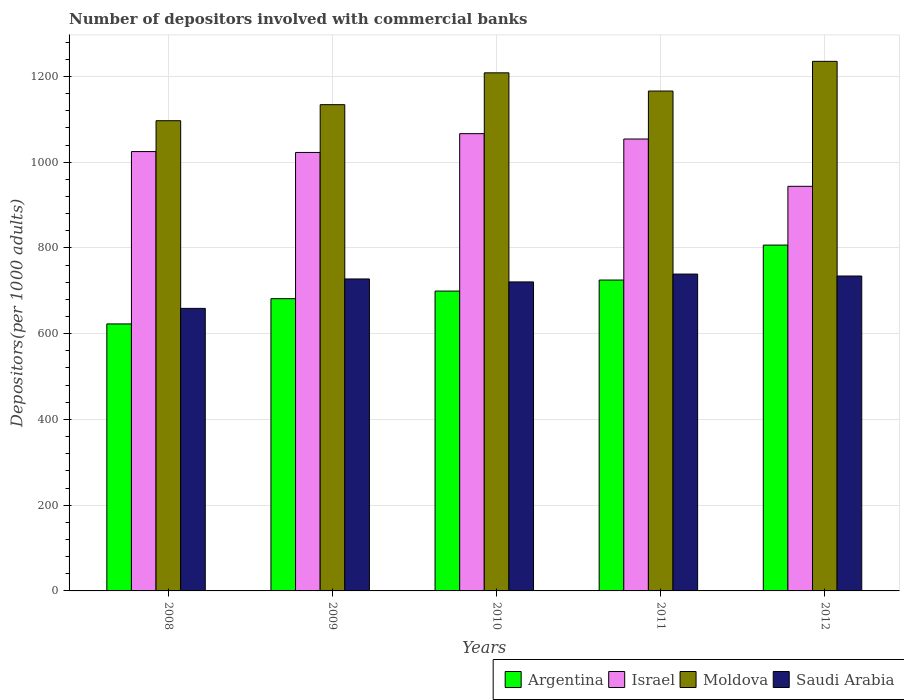How many groups of bars are there?
Give a very brief answer. 5. Are the number of bars per tick equal to the number of legend labels?
Provide a short and direct response. Yes. What is the number of depositors involved with commercial banks in Saudi Arabia in 2011?
Your answer should be very brief. 739.05. Across all years, what is the maximum number of depositors involved with commercial banks in Argentina?
Give a very brief answer. 806.63. Across all years, what is the minimum number of depositors involved with commercial banks in Argentina?
Your answer should be very brief. 622.73. In which year was the number of depositors involved with commercial banks in Israel minimum?
Your response must be concise. 2012. What is the total number of depositors involved with commercial banks in Israel in the graph?
Your answer should be very brief. 5111.81. What is the difference between the number of depositors involved with commercial banks in Argentina in 2011 and that in 2012?
Your answer should be very brief. -81.53. What is the difference between the number of depositors involved with commercial banks in Argentina in 2011 and the number of depositors involved with commercial banks in Moldova in 2009?
Offer a terse response. -409.07. What is the average number of depositors involved with commercial banks in Moldova per year?
Provide a succinct answer. 1168.08. In the year 2009, what is the difference between the number of depositors involved with commercial banks in Israel and number of depositors involved with commercial banks in Argentina?
Make the answer very short. 341.08. In how many years, is the number of depositors involved with commercial banks in Argentina greater than 880?
Your response must be concise. 0. What is the ratio of the number of depositors involved with commercial banks in Israel in 2008 to that in 2012?
Offer a very short reply. 1.09. Is the difference between the number of depositors involved with commercial banks in Israel in 2009 and 2010 greater than the difference between the number of depositors involved with commercial banks in Argentina in 2009 and 2010?
Your answer should be compact. No. What is the difference between the highest and the second highest number of depositors involved with commercial banks in Argentina?
Provide a short and direct response. 81.53. What is the difference between the highest and the lowest number of depositors involved with commercial banks in Argentina?
Ensure brevity in your answer.  183.9. Is the sum of the number of depositors involved with commercial banks in Israel in 2008 and 2011 greater than the maximum number of depositors involved with commercial banks in Moldova across all years?
Provide a short and direct response. Yes. Is it the case that in every year, the sum of the number of depositors involved with commercial banks in Israel and number of depositors involved with commercial banks in Argentina is greater than the sum of number of depositors involved with commercial banks in Moldova and number of depositors involved with commercial banks in Saudi Arabia?
Provide a succinct answer. Yes. What does the 4th bar from the right in 2012 represents?
Offer a very short reply. Argentina. How many bars are there?
Offer a terse response. 20. Does the graph contain any zero values?
Your response must be concise. No. How many legend labels are there?
Your response must be concise. 4. What is the title of the graph?
Your answer should be very brief. Number of depositors involved with commercial banks. What is the label or title of the Y-axis?
Keep it short and to the point. Depositors(per 1000 adults). What is the Depositors(per 1000 adults) of Argentina in 2008?
Your answer should be compact. 622.73. What is the Depositors(per 1000 adults) of Israel in 2008?
Give a very brief answer. 1024.76. What is the Depositors(per 1000 adults) of Moldova in 2008?
Provide a short and direct response. 1096.73. What is the Depositors(per 1000 adults) of Saudi Arabia in 2008?
Your answer should be very brief. 659. What is the Depositors(per 1000 adults) of Argentina in 2009?
Provide a short and direct response. 681.62. What is the Depositors(per 1000 adults) of Israel in 2009?
Give a very brief answer. 1022.7. What is the Depositors(per 1000 adults) of Moldova in 2009?
Keep it short and to the point. 1134.17. What is the Depositors(per 1000 adults) in Saudi Arabia in 2009?
Give a very brief answer. 727.65. What is the Depositors(per 1000 adults) of Argentina in 2010?
Give a very brief answer. 699.37. What is the Depositors(per 1000 adults) of Israel in 2010?
Your answer should be very brief. 1066.56. What is the Depositors(per 1000 adults) of Moldova in 2010?
Your answer should be compact. 1208.39. What is the Depositors(per 1000 adults) in Saudi Arabia in 2010?
Your answer should be very brief. 720.71. What is the Depositors(per 1000 adults) of Argentina in 2011?
Keep it short and to the point. 725.1. What is the Depositors(per 1000 adults) of Israel in 2011?
Give a very brief answer. 1054.06. What is the Depositors(per 1000 adults) in Moldova in 2011?
Offer a terse response. 1165.93. What is the Depositors(per 1000 adults) of Saudi Arabia in 2011?
Offer a very short reply. 739.05. What is the Depositors(per 1000 adults) in Argentina in 2012?
Ensure brevity in your answer.  806.63. What is the Depositors(per 1000 adults) in Israel in 2012?
Your response must be concise. 943.72. What is the Depositors(per 1000 adults) of Moldova in 2012?
Keep it short and to the point. 1235.18. What is the Depositors(per 1000 adults) in Saudi Arabia in 2012?
Provide a succinct answer. 734.51. Across all years, what is the maximum Depositors(per 1000 adults) in Argentina?
Give a very brief answer. 806.63. Across all years, what is the maximum Depositors(per 1000 adults) of Israel?
Ensure brevity in your answer.  1066.56. Across all years, what is the maximum Depositors(per 1000 adults) of Moldova?
Ensure brevity in your answer.  1235.18. Across all years, what is the maximum Depositors(per 1000 adults) in Saudi Arabia?
Offer a very short reply. 739.05. Across all years, what is the minimum Depositors(per 1000 adults) of Argentina?
Offer a terse response. 622.73. Across all years, what is the minimum Depositors(per 1000 adults) in Israel?
Your response must be concise. 943.72. Across all years, what is the minimum Depositors(per 1000 adults) of Moldova?
Keep it short and to the point. 1096.73. Across all years, what is the minimum Depositors(per 1000 adults) in Saudi Arabia?
Offer a terse response. 659. What is the total Depositors(per 1000 adults) of Argentina in the graph?
Keep it short and to the point. 3535.46. What is the total Depositors(per 1000 adults) of Israel in the graph?
Make the answer very short. 5111.81. What is the total Depositors(per 1000 adults) in Moldova in the graph?
Provide a succinct answer. 5840.41. What is the total Depositors(per 1000 adults) in Saudi Arabia in the graph?
Give a very brief answer. 3580.92. What is the difference between the Depositors(per 1000 adults) in Argentina in 2008 and that in 2009?
Offer a terse response. -58.89. What is the difference between the Depositors(per 1000 adults) of Israel in 2008 and that in 2009?
Provide a succinct answer. 2.06. What is the difference between the Depositors(per 1000 adults) of Moldova in 2008 and that in 2009?
Your answer should be very brief. -37.44. What is the difference between the Depositors(per 1000 adults) of Saudi Arabia in 2008 and that in 2009?
Provide a succinct answer. -68.64. What is the difference between the Depositors(per 1000 adults) of Argentina in 2008 and that in 2010?
Your answer should be compact. -76.64. What is the difference between the Depositors(per 1000 adults) of Israel in 2008 and that in 2010?
Provide a short and direct response. -41.8. What is the difference between the Depositors(per 1000 adults) in Moldova in 2008 and that in 2010?
Your response must be concise. -111.66. What is the difference between the Depositors(per 1000 adults) in Saudi Arabia in 2008 and that in 2010?
Offer a very short reply. -61.71. What is the difference between the Depositors(per 1000 adults) in Argentina in 2008 and that in 2011?
Give a very brief answer. -102.37. What is the difference between the Depositors(per 1000 adults) in Israel in 2008 and that in 2011?
Ensure brevity in your answer.  -29.3. What is the difference between the Depositors(per 1000 adults) in Moldova in 2008 and that in 2011?
Provide a short and direct response. -69.2. What is the difference between the Depositors(per 1000 adults) in Saudi Arabia in 2008 and that in 2011?
Your response must be concise. -80.04. What is the difference between the Depositors(per 1000 adults) of Argentina in 2008 and that in 2012?
Your answer should be very brief. -183.9. What is the difference between the Depositors(per 1000 adults) of Israel in 2008 and that in 2012?
Provide a short and direct response. 81.04. What is the difference between the Depositors(per 1000 adults) of Moldova in 2008 and that in 2012?
Your answer should be very brief. -138.45. What is the difference between the Depositors(per 1000 adults) of Saudi Arabia in 2008 and that in 2012?
Offer a terse response. -75.51. What is the difference between the Depositors(per 1000 adults) in Argentina in 2009 and that in 2010?
Ensure brevity in your answer.  -17.75. What is the difference between the Depositors(per 1000 adults) of Israel in 2009 and that in 2010?
Your response must be concise. -43.86. What is the difference between the Depositors(per 1000 adults) in Moldova in 2009 and that in 2010?
Give a very brief answer. -74.22. What is the difference between the Depositors(per 1000 adults) in Saudi Arabia in 2009 and that in 2010?
Your answer should be compact. 6.93. What is the difference between the Depositors(per 1000 adults) in Argentina in 2009 and that in 2011?
Make the answer very short. -43.48. What is the difference between the Depositors(per 1000 adults) in Israel in 2009 and that in 2011?
Provide a succinct answer. -31.36. What is the difference between the Depositors(per 1000 adults) of Moldova in 2009 and that in 2011?
Your answer should be compact. -31.76. What is the difference between the Depositors(per 1000 adults) in Saudi Arabia in 2009 and that in 2011?
Your answer should be compact. -11.4. What is the difference between the Depositors(per 1000 adults) in Argentina in 2009 and that in 2012?
Offer a terse response. -125.01. What is the difference between the Depositors(per 1000 adults) in Israel in 2009 and that in 2012?
Provide a succinct answer. 78.98. What is the difference between the Depositors(per 1000 adults) in Moldova in 2009 and that in 2012?
Offer a very short reply. -101.01. What is the difference between the Depositors(per 1000 adults) in Saudi Arabia in 2009 and that in 2012?
Give a very brief answer. -6.87. What is the difference between the Depositors(per 1000 adults) of Argentina in 2010 and that in 2011?
Offer a terse response. -25.73. What is the difference between the Depositors(per 1000 adults) in Israel in 2010 and that in 2011?
Your answer should be compact. 12.5. What is the difference between the Depositors(per 1000 adults) of Moldova in 2010 and that in 2011?
Your answer should be compact. 42.46. What is the difference between the Depositors(per 1000 adults) of Saudi Arabia in 2010 and that in 2011?
Offer a very short reply. -18.33. What is the difference between the Depositors(per 1000 adults) of Argentina in 2010 and that in 2012?
Ensure brevity in your answer.  -107.26. What is the difference between the Depositors(per 1000 adults) in Israel in 2010 and that in 2012?
Your answer should be very brief. 122.84. What is the difference between the Depositors(per 1000 adults) of Moldova in 2010 and that in 2012?
Give a very brief answer. -26.79. What is the difference between the Depositors(per 1000 adults) in Saudi Arabia in 2010 and that in 2012?
Make the answer very short. -13.8. What is the difference between the Depositors(per 1000 adults) of Argentina in 2011 and that in 2012?
Your answer should be compact. -81.53. What is the difference between the Depositors(per 1000 adults) in Israel in 2011 and that in 2012?
Offer a terse response. 110.33. What is the difference between the Depositors(per 1000 adults) in Moldova in 2011 and that in 2012?
Keep it short and to the point. -69.25. What is the difference between the Depositors(per 1000 adults) of Saudi Arabia in 2011 and that in 2012?
Offer a very short reply. 4.54. What is the difference between the Depositors(per 1000 adults) of Argentina in 2008 and the Depositors(per 1000 adults) of Israel in 2009?
Your answer should be compact. -399.97. What is the difference between the Depositors(per 1000 adults) of Argentina in 2008 and the Depositors(per 1000 adults) of Moldova in 2009?
Ensure brevity in your answer.  -511.44. What is the difference between the Depositors(per 1000 adults) of Argentina in 2008 and the Depositors(per 1000 adults) of Saudi Arabia in 2009?
Your response must be concise. -104.91. What is the difference between the Depositors(per 1000 adults) of Israel in 2008 and the Depositors(per 1000 adults) of Moldova in 2009?
Offer a terse response. -109.41. What is the difference between the Depositors(per 1000 adults) of Israel in 2008 and the Depositors(per 1000 adults) of Saudi Arabia in 2009?
Make the answer very short. 297.12. What is the difference between the Depositors(per 1000 adults) of Moldova in 2008 and the Depositors(per 1000 adults) of Saudi Arabia in 2009?
Keep it short and to the point. 369.08. What is the difference between the Depositors(per 1000 adults) in Argentina in 2008 and the Depositors(per 1000 adults) in Israel in 2010?
Your answer should be very brief. -443.83. What is the difference between the Depositors(per 1000 adults) of Argentina in 2008 and the Depositors(per 1000 adults) of Moldova in 2010?
Your response must be concise. -585.66. What is the difference between the Depositors(per 1000 adults) in Argentina in 2008 and the Depositors(per 1000 adults) in Saudi Arabia in 2010?
Provide a succinct answer. -97.98. What is the difference between the Depositors(per 1000 adults) in Israel in 2008 and the Depositors(per 1000 adults) in Moldova in 2010?
Your answer should be very brief. -183.63. What is the difference between the Depositors(per 1000 adults) of Israel in 2008 and the Depositors(per 1000 adults) of Saudi Arabia in 2010?
Offer a very short reply. 304.05. What is the difference between the Depositors(per 1000 adults) of Moldova in 2008 and the Depositors(per 1000 adults) of Saudi Arabia in 2010?
Provide a short and direct response. 376.02. What is the difference between the Depositors(per 1000 adults) in Argentina in 2008 and the Depositors(per 1000 adults) in Israel in 2011?
Give a very brief answer. -431.32. What is the difference between the Depositors(per 1000 adults) in Argentina in 2008 and the Depositors(per 1000 adults) in Moldova in 2011?
Give a very brief answer. -543.2. What is the difference between the Depositors(per 1000 adults) in Argentina in 2008 and the Depositors(per 1000 adults) in Saudi Arabia in 2011?
Your answer should be very brief. -116.31. What is the difference between the Depositors(per 1000 adults) of Israel in 2008 and the Depositors(per 1000 adults) of Moldova in 2011?
Keep it short and to the point. -141.17. What is the difference between the Depositors(per 1000 adults) of Israel in 2008 and the Depositors(per 1000 adults) of Saudi Arabia in 2011?
Offer a very short reply. 285.72. What is the difference between the Depositors(per 1000 adults) of Moldova in 2008 and the Depositors(per 1000 adults) of Saudi Arabia in 2011?
Keep it short and to the point. 357.68. What is the difference between the Depositors(per 1000 adults) in Argentina in 2008 and the Depositors(per 1000 adults) in Israel in 2012?
Offer a terse response. -320.99. What is the difference between the Depositors(per 1000 adults) of Argentina in 2008 and the Depositors(per 1000 adults) of Moldova in 2012?
Your answer should be compact. -612.45. What is the difference between the Depositors(per 1000 adults) of Argentina in 2008 and the Depositors(per 1000 adults) of Saudi Arabia in 2012?
Your response must be concise. -111.78. What is the difference between the Depositors(per 1000 adults) in Israel in 2008 and the Depositors(per 1000 adults) in Moldova in 2012?
Offer a terse response. -210.42. What is the difference between the Depositors(per 1000 adults) of Israel in 2008 and the Depositors(per 1000 adults) of Saudi Arabia in 2012?
Provide a short and direct response. 290.25. What is the difference between the Depositors(per 1000 adults) of Moldova in 2008 and the Depositors(per 1000 adults) of Saudi Arabia in 2012?
Make the answer very short. 362.22. What is the difference between the Depositors(per 1000 adults) in Argentina in 2009 and the Depositors(per 1000 adults) in Israel in 2010?
Make the answer very short. -384.94. What is the difference between the Depositors(per 1000 adults) of Argentina in 2009 and the Depositors(per 1000 adults) of Moldova in 2010?
Offer a terse response. -526.77. What is the difference between the Depositors(per 1000 adults) of Argentina in 2009 and the Depositors(per 1000 adults) of Saudi Arabia in 2010?
Your response must be concise. -39.09. What is the difference between the Depositors(per 1000 adults) in Israel in 2009 and the Depositors(per 1000 adults) in Moldova in 2010?
Give a very brief answer. -185.69. What is the difference between the Depositors(per 1000 adults) in Israel in 2009 and the Depositors(per 1000 adults) in Saudi Arabia in 2010?
Provide a short and direct response. 301.99. What is the difference between the Depositors(per 1000 adults) in Moldova in 2009 and the Depositors(per 1000 adults) in Saudi Arabia in 2010?
Your answer should be very brief. 413.46. What is the difference between the Depositors(per 1000 adults) in Argentina in 2009 and the Depositors(per 1000 adults) in Israel in 2011?
Give a very brief answer. -372.44. What is the difference between the Depositors(per 1000 adults) in Argentina in 2009 and the Depositors(per 1000 adults) in Moldova in 2011?
Ensure brevity in your answer.  -484.31. What is the difference between the Depositors(per 1000 adults) in Argentina in 2009 and the Depositors(per 1000 adults) in Saudi Arabia in 2011?
Ensure brevity in your answer.  -57.43. What is the difference between the Depositors(per 1000 adults) in Israel in 2009 and the Depositors(per 1000 adults) in Moldova in 2011?
Your answer should be very brief. -143.23. What is the difference between the Depositors(per 1000 adults) of Israel in 2009 and the Depositors(per 1000 adults) of Saudi Arabia in 2011?
Make the answer very short. 283.65. What is the difference between the Depositors(per 1000 adults) of Moldova in 2009 and the Depositors(per 1000 adults) of Saudi Arabia in 2011?
Provide a short and direct response. 395.13. What is the difference between the Depositors(per 1000 adults) of Argentina in 2009 and the Depositors(per 1000 adults) of Israel in 2012?
Your answer should be compact. -262.11. What is the difference between the Depositors(per 1000 adults) in Argentina in 2009 and the Depositors(per 1000 adults) in Moldova in 2012?
Provide a succinct answer. -553.57. What is the difference between the Depositors(per 1000 adults) of Argentina in 2009 and the Depositors(per 1000 adults) of Saudi Arabia in 2012?
Provide a short and direct response. -52.89. What is the difference between the Depositors(per 1000 adults) of Israel in 2009 and the Depositors(per 1000 adults) of Moldova in 2012?
Give a very brief answer. -212.48. What is the difference between the Depositors(per 1000 adults) of Israel in 2009 and the Depositors(per 1000 adults) of Saudi Arabia in 2012?
Provide a short and direct response. 288.19. What is the difference between the Depositors(per 1000 adults) of Moldova in 2009 and the Depositors(per 1000 adults) of Saudi Arabia in 2012?
Keep it short and to the point. 399.66. What is the difference between the Depositors(per 1000 adults) of Argentina in 2010 and the Depositors(per 1000 adults) of Israel in 2011?
Make the answer very short. -354.69. What is the difference between the Depositors(per 1000 adults) in Argentina in 2010 and the Depositors(per 1000 adults) in Moldova in 2011?
Make the answer very short. -466.56. What is the difference between the Depositors(per 1000 adults) of Argentina in 2010 and the Depositors(per 1000 adults) of Saudi Arabia in 2011?
Keep it short and to the point. -39.68. What is the difference between the Depositors(per 1000 adults) in Israel in 2010 and the Depositors(per 1000 adults) in Moldova in 2011?
Your response must be concise. -99.37. What is the difference between the Depositors(per 1000 adults) in Israel in 2010 and the Depositors(per 1000 adults) in Saudi Arabia in 2011?
Ensure brevity in your answer.  327.52. What is the difference between the Depositors(per 1000 adults) in Moldova in 2010 and the Depositors(per 1000 adults) in Saudi Arabia in 2011?
Offer a terse response. 469.34. What is the difference between the Depositors(per 1000 adults) in Argentina in 2010 and the Depositors(per 1000 adults) in Israel in 2012?
Provide a succinct answer. -244.35. What is the difference between the Depositors(per 1000 adults) in Argentina in 2010 and the Depositors(per 1000 adults) in Moldova in 2012?
Keep it short and to the point. -535.81. What is the difference between the Depositors(per 1000 adults) of Argentina in 2010 and the Depositors(per 1000 adults) of Saudi Arabia in 2012?
Offer a very short reply. -35.14. What is the difference between the Depositors(per 1000 adults) in Israel in 2010 and the Depositors(per 1000 adults) in Moldova in 2012?
Keep it short and to the point. -168.62. What is the difference between the Depositors(per 1000 adults) in Israel in 2010 and the Depositors(per 1000 adults) in Saudi Arabia in 2012?
Give a very brief answer. 332.05. What is the difference between the Depositors(per 1000 adults) in Moldova in 2010 and the Depositors(per 1000 adults) in Saudi Arabia in 2012?
Provide a short and direct response. 473.88. What is the difference between the Depositors(per 1000 adults) in Argentina in 2011 and the Depositors(per 1000 adults) in Israel in 2012?
Your response must be concise. -218.62. What is the difference between the Depositors(per 1000 adults) of Argentina in 2011 and the Depositors(per 1000 adults) of Moldova in 2012?
Offer a very short reply. -510.08. What is the difference between the Depositors(per 1000 adults) of Argentina in 2011 and the Depositors(per 1000 adults) of Saudi Arabia in 2012?
Keep it short and to the point. -9.41. What is the difference between the Depositors(per 1000 adults) in Israel in 2011 and the Depositors(per 1000 adults) in Moldova in 2012?
Offer a terse response. -181.13. What is the difference between the Depositors(per 1000 adults) in Israel in 2011 and the Depositors(per 1000 adults) in Saudi Arabia in 2012?
Your response must be concise. 319.55. What is the difference between the Depositors(per 1000 adults) in Moldova in 2011 and the Depositors(per 1000 adults) in Saudi Arabia in 2012?
Your answer should be compact. 431.42. What is the average Depositors(per 1000 adults) of Argentina per year?
Ensure brevity in your answer.  707.09. What is the average Depositors(per 1000 adults) in Israel per year?
Make the answer very short. 1022.36. What is the average Depositors(per 1000 adults) in Moldova per year?
Provide a short and direct response. 1168.08. What is the average Depositors(per 1000 adults) in Saudi Arabia per year?
Your response must be concise. 716.18. In the year 2008, what is the difference between the Depositors(per 1000 adults) of Argentina and Depositors(per 1000 adults) of Israel?
Offer a very short reply. -402.03. In the year 2008, what is the difference between the Depositors(per 1000 adults) of Argentina and Depositors(per 1000 adults) of Moldova?
Provide a succinct answer. -474. In the year 2008, what is the difference between the Depositors(per 1000 adults) of Argentina and Depositors(per 1000 adults) of Saudi Arabia?
Give a very brief answer. -36.27. In the year 2008, what is the difference between the Depositors(per 1000 adults) of Israel and Depositors(per 1000 adults) of Moldova?
Your answer should be compact. -71.97. In the year 2008, what is the difference between the Depositors(per 1000 adults) of Israel and Depositors(per 1000 adults) of Saudi Arabia?
Provide a short and direct response. 365.76. In the year 2008, what is the difference between the Depositors(per 1000 adults) of Moldova and Depositors(per 1000 adults) of Saudi Arabia?
Ensure brevity in your answer.  437.73. In the year 2009, what is the difference between the Depositors(per 1000 adults) of Argentina and Depositors(per 1000 adults) of Israel?
Give a very brief answer. -341.08. In the year 2009, what is the difference between the Depositors(per 1000 adults) in Argentina and Depositors(per 1000 adults) in Moldova?
Your answer should be very brief. -452.56. In the year 2009, what is the difference between the Depositors(per 1000 adults) in Argentina and Depositors(per 1000 adults) in Saudi Arabia?
Make the answer very short. -46.03. In the year 2009, what is the difference between the Depositors(per 1000 adults) of Israel and Depositors(per 1000 adults) of Moldova?
Provide a short and direct response. -111.47. In the year 2009, what is the difference between the Depositors(per 1000 adults) in Israel and Depositors(per 1000 adults) in Saudi Arabia?
Ensure brevity in your answer.  295.05. In the year 2009, what is the difference between the Depositors(per 1000 adults) in Moldova and Depositors(per 1000 adults) in Saudi Arabia?
Provide a succinct answer. 406.53. In the year 2010, what is the difference between the Depositors(per 1000 adults) of Argentina and Depositors(per 1000 adults) of Israel?
Your answer should be compact. -367.19. In the year 2010, what is the difference between the Depositors(per 1000 adults) of Argentina and Depositors(per 1000 adults) of Moldova?
Keep it short and to the point. -509.02. In the year 2010, what is the difference between the Depositors(per 1000 adults) in Argentina and Depositors(per 1000 adults) in Saudi Arabia?
Provide a succinct answer. -21.34. In the year 2010, what is the difference between the Depositors(per 1000 adults) in Israel and Depositors(per 1000 adults) in Moldova?
Provide a succinct answer. -141.83. In the year 2010, what is the difference between the Depositors(per 1000 adults) of Israel and Depositors(per 1000 adults) of Saudi Arabia?
Give a very brief answer. 345.85. In the year 2010, what is the difference between the Depositors(per 1000 adults) in Moldova and Depositors(per 1000 adults) in Saudi Arabia?
Offer a very short reply. 487.68. In the year 2011, what is the difference between the Depositors(per 1000 adults) in Argentina and Depositors(per 1000 adults) in Israel?
Your answer should be compact. -328.95. In the year 2011, what is the difference between the Depositors(per 1000 adults) in Argentina and Depositors(per 1000 adults) in Moldova?
Ensure brevity in your answer.  -440.83. In the year 2011, what is the difference between the Depositors(per 1000 adults) of Argentina and Depositors(per 1000 adults) of Saudi Arabia?
Provide a short and direct response. -13.94. In the year 2011, what is the difference between the Depositors(per 1000 adults) in Israel and Depositors(per 1000 adults) in Moldova?
Offer a very short reply. -111.87. In the year 2011, what is the difference between the Depositors(per 1000 adults) in Israel and Depositors(per 1000 adults) in Saudi Arabia?
Ensure brevity in your answer.  315.01. In the year 2011, what is the difference between the Depositors(per 1000 adults) of Moldova and Depositors(per 1000 adults) of Saudi Arabia?
Offer a very short reply. 426.88. In the year 2012, what is the difference between the Depositors(per 1000 adults) in Argentina and Depositors(per 1000 adults) in Israel?
Your response must be concise. -137.09. In the year 2012, what is the difference between the Depositors(per 1000 adults) of Argentina and Depositors(per 1000 adults) of Moldova?
Offer a very short reply. -428.55. In the year 2012, what is the difference between the Depositors(per 1000 adults) of Argentina and Depositors(per 1000 adults) of Saudi Arabia?
Offer a terse response. 72.12. In the year 2012, what is the difference between the Depositors(per 1000 adults) in Israel and Depositors(per 1000 adults) in Moldova?
Provide a short and direct response. -291.46. In the year 2012, what is the difference between the Depositors(per 1000 adults) of Israel and Depositors(per 1000 adults) of Saudi Arabia?
Your answer should be very brief. 209.21. In the year 2012, what is the difference between the Depositors(per 1000 adults) in Moldova and Depositors(per 1000 adults) in Saudi Arabia?
Offer a terse response. 500.67. What is the ratio of the Depositors(per 1000 adults) in Argentina in 2008 to that in 2009?
Offer a very short reply. 0.91. What is the ratio of the Depositors(per 1000 adults) of Saudi Arabia in 2008 to that in 2009?
Your response must be concise. 0.91. What is the ratio of the Depositors(per 1000 adults) in Argentina in 2008 to that in 2010?
Your answer should be very brief. 0.89. What is the ratio of the Depositors(per 1000 adults) of Israel in 2008 to that in 2010?
Your answer should be very brief. 0.96. What is the ratio of the Depositors(per 1000 adults) in Moldova in 2008 to that in 2010?
Make the answer very short. 0.91. What is the ratio of the Depositors(per 1000 adults) in Saudi Arabia in 2008 to that in 2010?
Your answer should be very brief. 0.91. What is the ratio of the Depositors(per 1000 adults) in Argentina in 2008 to that in 2011?
Give a very brief answer. 0.86. What is the ratio of the Depositors(per 1000 adults) of Israel in 2008 to that in 2011?
Make the answer very short. 0.97. What is the ratio of the Depositors(per 1000 adults) of Moldova in 2008 to that in 2011?
Ensure brevity in your answer.  0.94. What is the ratio of the Depositors(per 1000 adults) in Saudi Arabia in 2008 to that in 2011?
Your response must be concise. 0.89. What is the ratio of the Depositors(per 1000 adults) in Argentina in 2008 to that in 2012?
Your answer should be very brief. 0.77. What is the ratio of the Depositors(per 1000 adults) of Israel in 2008 to that in 2012?
Give a very brief answer. 1.09. What is the ratio of the Depositors(per 1000 adults) of Moldova in 2008 to that in 2012?
Give a very brief answer. 0.89. What is the ratio of the Depositors(per 1000 adults) in Saudi Arabia in 2008 to that in 2012?
Your response must be concise. 0.9. What is the ratio of the Depositors(per 1000 adults) of Argentina in 2009 to that in 2010?
Your answer should be compact. 0.97. What is the ratio of the Depositors(per 1000 adults) of Israel in 2009 to that in 2010?
Keep it short and to the point. 0.96. What is the ratio of the Depositors(per 1000 adults) in Moldova in 2009 to that in 2010?
Offer a terse response. 0.94. What is the ratio of the Depositors(per 1000 adults) in Saudi Arabia in 2009 to that in 2010?
Your response must be concise. 1.01. What is the ratio of the Depositors(per 1000 adults) in Israel in 2009 to that in 2011?
Give a very brief answer. 0.97. What is the ratio of the Depositors(per 1000 adults) in Moldova in 2009 to that in 2011?
Make the answer very short. 0.97. What is the ratio of the Depositors(per 1000 adults) in Saudi Arabia in 2009 to that in 2011?
Provide a short and direct response. 0.98. What is the ratio of the Depositors(per 1000 adults) in Argentina in 2009 to that in 2012?
Your answer should be very brief. 0.84. What is the ratio of the Depositors(per 1000 adults) in Israel in 2009 to that in 2012?
Your answer should be compact. 1.08. What is the ratio of the Depositors(per 1000 adults) in Moldova in 2009 to that in 2012?
Keep it short and to the point. 0.92. What is the ratio of the Depositors(per 1000 adults) of Saudi Arabia in 2009 to that in 2012?
Keep it short and to the point. 0.99. What is the ratio of the Depositors(per 1000 adults) in Argentina in 2010 to that in 2011?
Your response must be concise. 0.96. What is the ratio of the Depositors(per 1000 adults) of Israel in 2010 to that in 2011?
Provide a short and direct response. 1.01. What is the ratio of the Depositors(per 1000 adults) in Moldova in 2010 to that in 2011?
Offer a very short reply. 1.04. What is the ratio of the Depositors(per 1000 adults) in Saudi Arabia in 2010 to that in 2011?
Give a very brief answer. 0.98. What is the ratio of the Depositors(per 1000 adults) of Argentina in 2010 to that in 2012?
Ensure brevity in your answer.  0.87. What is the ratio of the Depositors(per 1000 adults) in Israel in 2010 to that in 2012?
Ensure brevity in your answer.  1.13. What is the ratio of the Depositors(per 1000 adults) in Moldova in 2010 to that in 2012?
Ensure brevity in your answer.  0.98. What is the ratio of the Depositors(per 1000 adults) in Saudi Arabia in 2010 to that in 2012?
Offer a terse response. 0.98. What is the ratio of the Depositors(per 1000 adults) in Argentina in 2011 to that in 2012?
Provide a short and direct response. 0.9. What is the ratio of the Depositors(per 1000 adults) of Israel in 2011 to that in 2012?
Keep it short and to the point. 1.12. What is the ratio of the Depositors(per 1000 adults) in Moldova in 2011 to that in 2012?
Your response must be concise. 0.94. What is the difference between the highest and the second highest Depositors(per 1000 adults) in Argentina?
Offer a terse response. 81.53. What is the difference between the highest and the second highest Depositors(per 1000 adults) of Israel?
Ensure brevity in your answer.  12.5. What is the difference between the highest and the second highest Depositors(per 1000 adults) of Moldova?
Provide a succinct answer. 26.79. What is the difference between the highest and the second highest Depositors(per 1000 adults) in Saudi Arabia?
Make the answer very short. 4.54. What is the difference between the highest and the lowest Depositors(per 1000 adults) of Argentina?
Keep it short and to the point. 183.9. What is the difference between the highest and the lowest Depositors(per 1000 adults) in Israel?
Give a very brief answer. 122.84. What is the difference between the highest and the lowest Depositors(per 1000 adults) in Moldova?
Your answer should be very brief. 138.45. What is the difference between the highest and the lowest Depositors(per 1000 adults) of Saudi Arabia?
Your response must be concise. 80.04. 